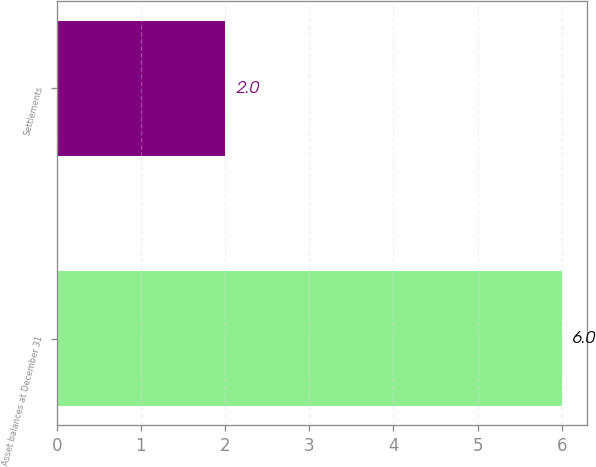Convert chart. <chart><loc_0><loc_0><loc_500><loc_500><bar_chart><fcel>Asset balances at December 31<fcel>Settlements<nl><fcel>6<fcel>2<nl></chart> 